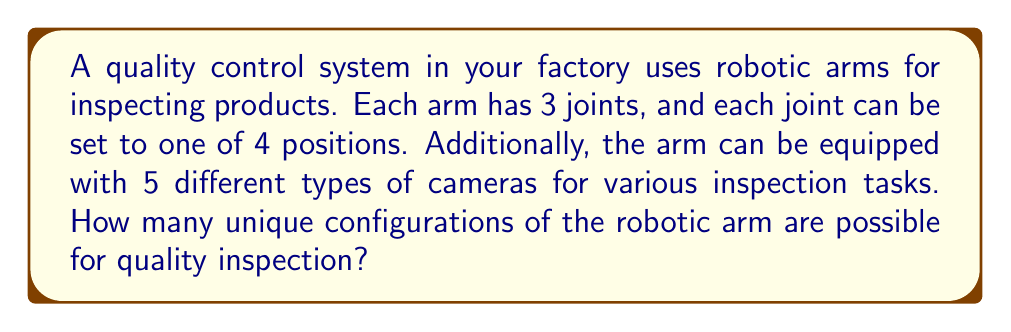Provide a solution to this math problem. Let's break this down step-by-step:

1) First, let's consider the arm configuration without the camera:
   - There are 3 joints, each with 4 possible positions.
   - For each joint, we have 4 choices, independent of the other joints.
   - This is a multiplication principle problem.
   - Number of arm configurations = $4 \times 4 \times 4 = 4^3 = 64$

2) Now, for each of these arm configurations, we have 5 choices of cameras.
   - This is another application of the multiplication principle.
   - Total configurations = (Arm configurations) $\times$ (Camera choices)
   - Total configurations = $64 \times 5 = 320$

3) We can express this mathematically as:

   $$\text{Total Configurations} = 4^3 \times 5 = 320$$

   Where $4^3$ represents the arm joint configurations and 5 represents the camera choices.

This calculation gives us the total number of unique ways we can configure the robotic arm for quality inspection, considering both the arm positions and the choice of camera.
Answer: 320 